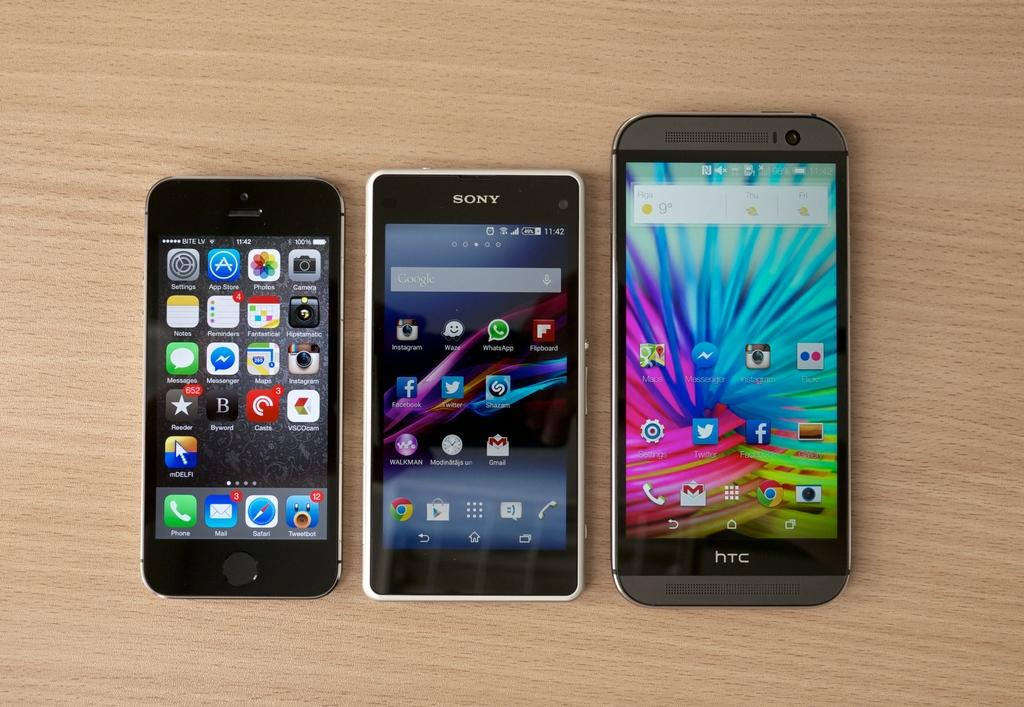<image>
Write a terse but informative summary of the picture. A group of cellphones include HTC and Sony models. 